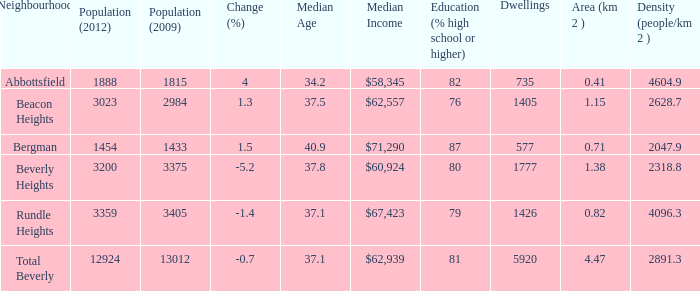Can you parse all the data within this table? {'header': ['Neighbourhood', 'Population (2012)', 'Population (2009)', 'Change (%)', 'Median Age', 'Median Income', 'Education (% high school or higher)', 'Dwellings', 'Area (km 2 )', 'Density (people/km 2 )'], 'rows': [['Abbottsfield', '1888', '1815', '4', '34.2', '$58,345', '82', '735', '0.41', '4604.9'], ['Beacon Heights', '3023', '2984', '1.3', '37.5', '$62,557', '76', '1405', '1.15', '2628.7'], ['Bergman', '1454', '1433', '1.5', '40.9', '$71,290', '87', '577', '0.71', '2047.9'], ['Beverly Heights', '3200', '3375', '-5.2', '37.8', '$60,924', '80', '1777', '1.38', '2318.8'], ['Rundle Heights', '3359', '3405', '-1.4', '37.1', '$67,423', '79', '1426', '0.82', '4096.3'], ['Total Beverly', '12924', '13012', '-0.7', '37.1', '$62,939', '81', '5920', '4.47', '2891.3']]} How many Dwellings does Beverly Heights have that have a change percent larger than -5.2? None. 